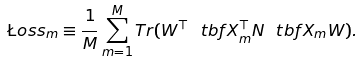<formula> <loc_0><loc_0><loc_500><loc_500>\L o s s _ { m } \equiv \frac { 1 } { M } \sum _ { m = 1 } ^ { M } T r ( W ^ { \top } \ t b f X _ { m } ^ { \top } N \ t b f X _ { m } W ) .</formula> 